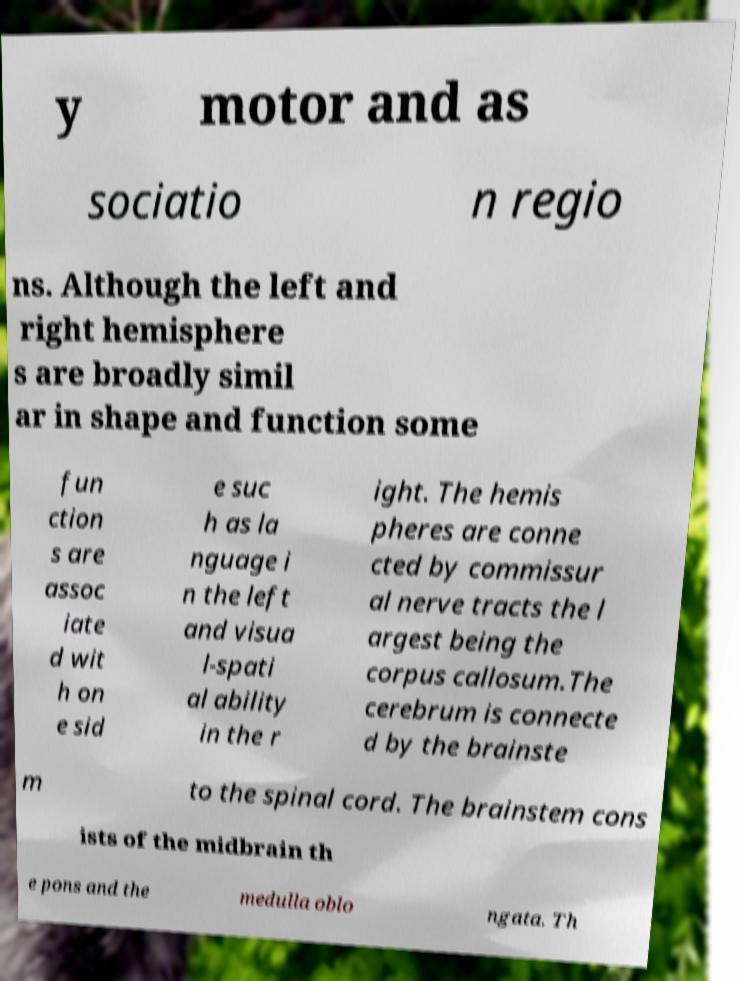Could you assist in decoding the text presented in this image and type it out clearly? y motor and as sociatio n regio ns. Although the left and right hemisphere s are broadly simil ar in shape and function some fun ction s are assoc iate d wit h on e sid e suc h as la nguage i n the left and visua l-spati al ability in the r ight. The hemis pheres are conne cted by commissur al nerve tracts the l argest being the corpus callosum.The cerebrum is connecte d by the brainste m to the spinal cord. The brainstem cons ists of the midbrain th e pons and the medulla oblo ngata. Th 